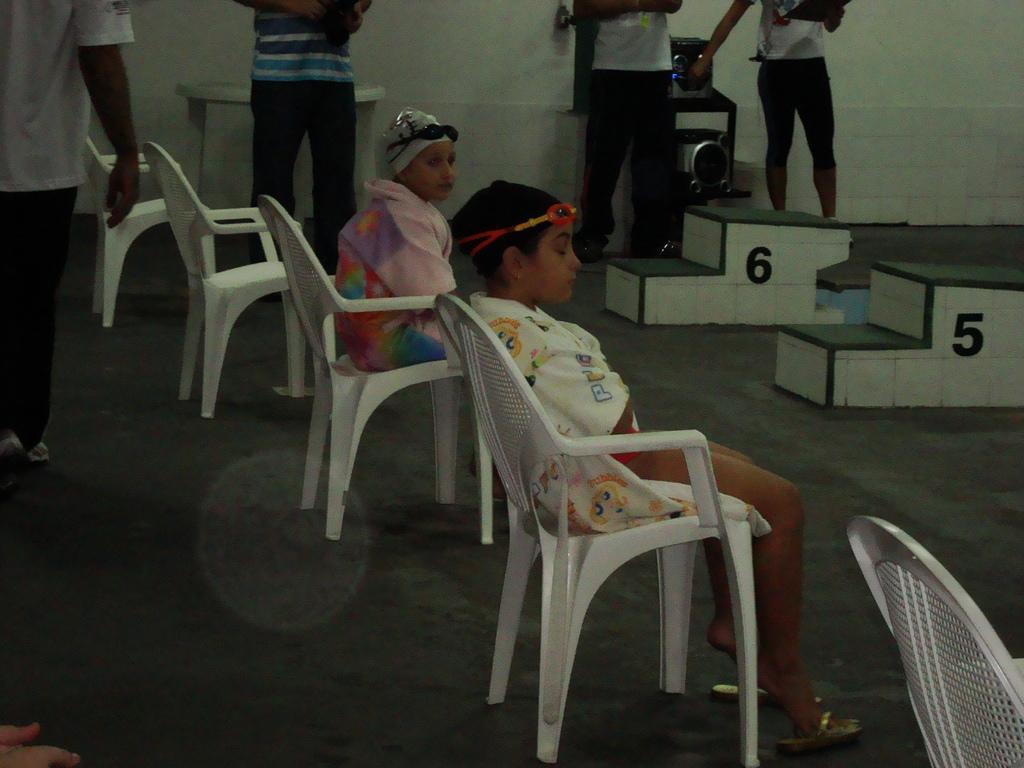Describe this image in one or two sentences. It is a swimming are, two kids are sitting on the chair wearing swimming costume , beside them there are four men standing, to the right side of the kid there are two steps , beside the steps there is a speaker and a music system. 